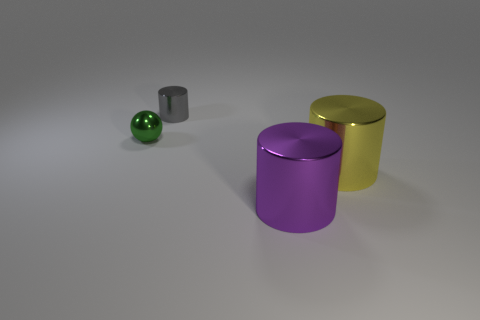What number of big shiny objects are on the right side of the metal thing on the left side of the small gray metallic cylinder?
Make the answer very short. 2. Are the tiny object that is in front of the gray shiny object and the big purple cylinder made of the same material?
Keep it short and to the point. Yes. There is a purple object in front of the small metal thing that is behind the green shiny object; what size is it?
Provide a succinct answer. Large. There is a yellow metallic object right of the shiny cylinder that is behind the tiny green shiny ball that is behind the big yellow thing; what is its size?
Ensure brevity in your answer.  Large. Is the shape of the large metallic object to the right of the purple metallic object the same as the big thing that is in front of the big yellow shiny object?
Your answer should be compact. Yes. How many other things are the same color as the tiny cylinder?
Your answer should be compact. 0. There is a cylinder that is behind the green metal ball; is its size the same as the green shiny object?
Your response must be concise. Yes. Does the small thing left of the gray shiny cylinder have the same material as the small object to the right of the tiny metal sphere?
Your answer should be compact. Yes. Are there any objects of the same size as the green sphere?
Offer a terse response. Yes. What shape is the tiny green metal object that is left of the metal object that is on the right side of the big object that is in front of the large yellow thing?
Offer a very short reply. Sphere. 